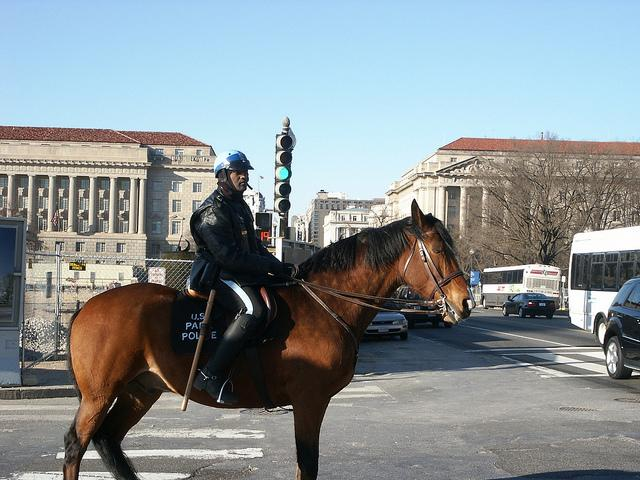Why is he on a horse? Please explain your reasoning. is patrolling. A police officer is keeping the city safe 